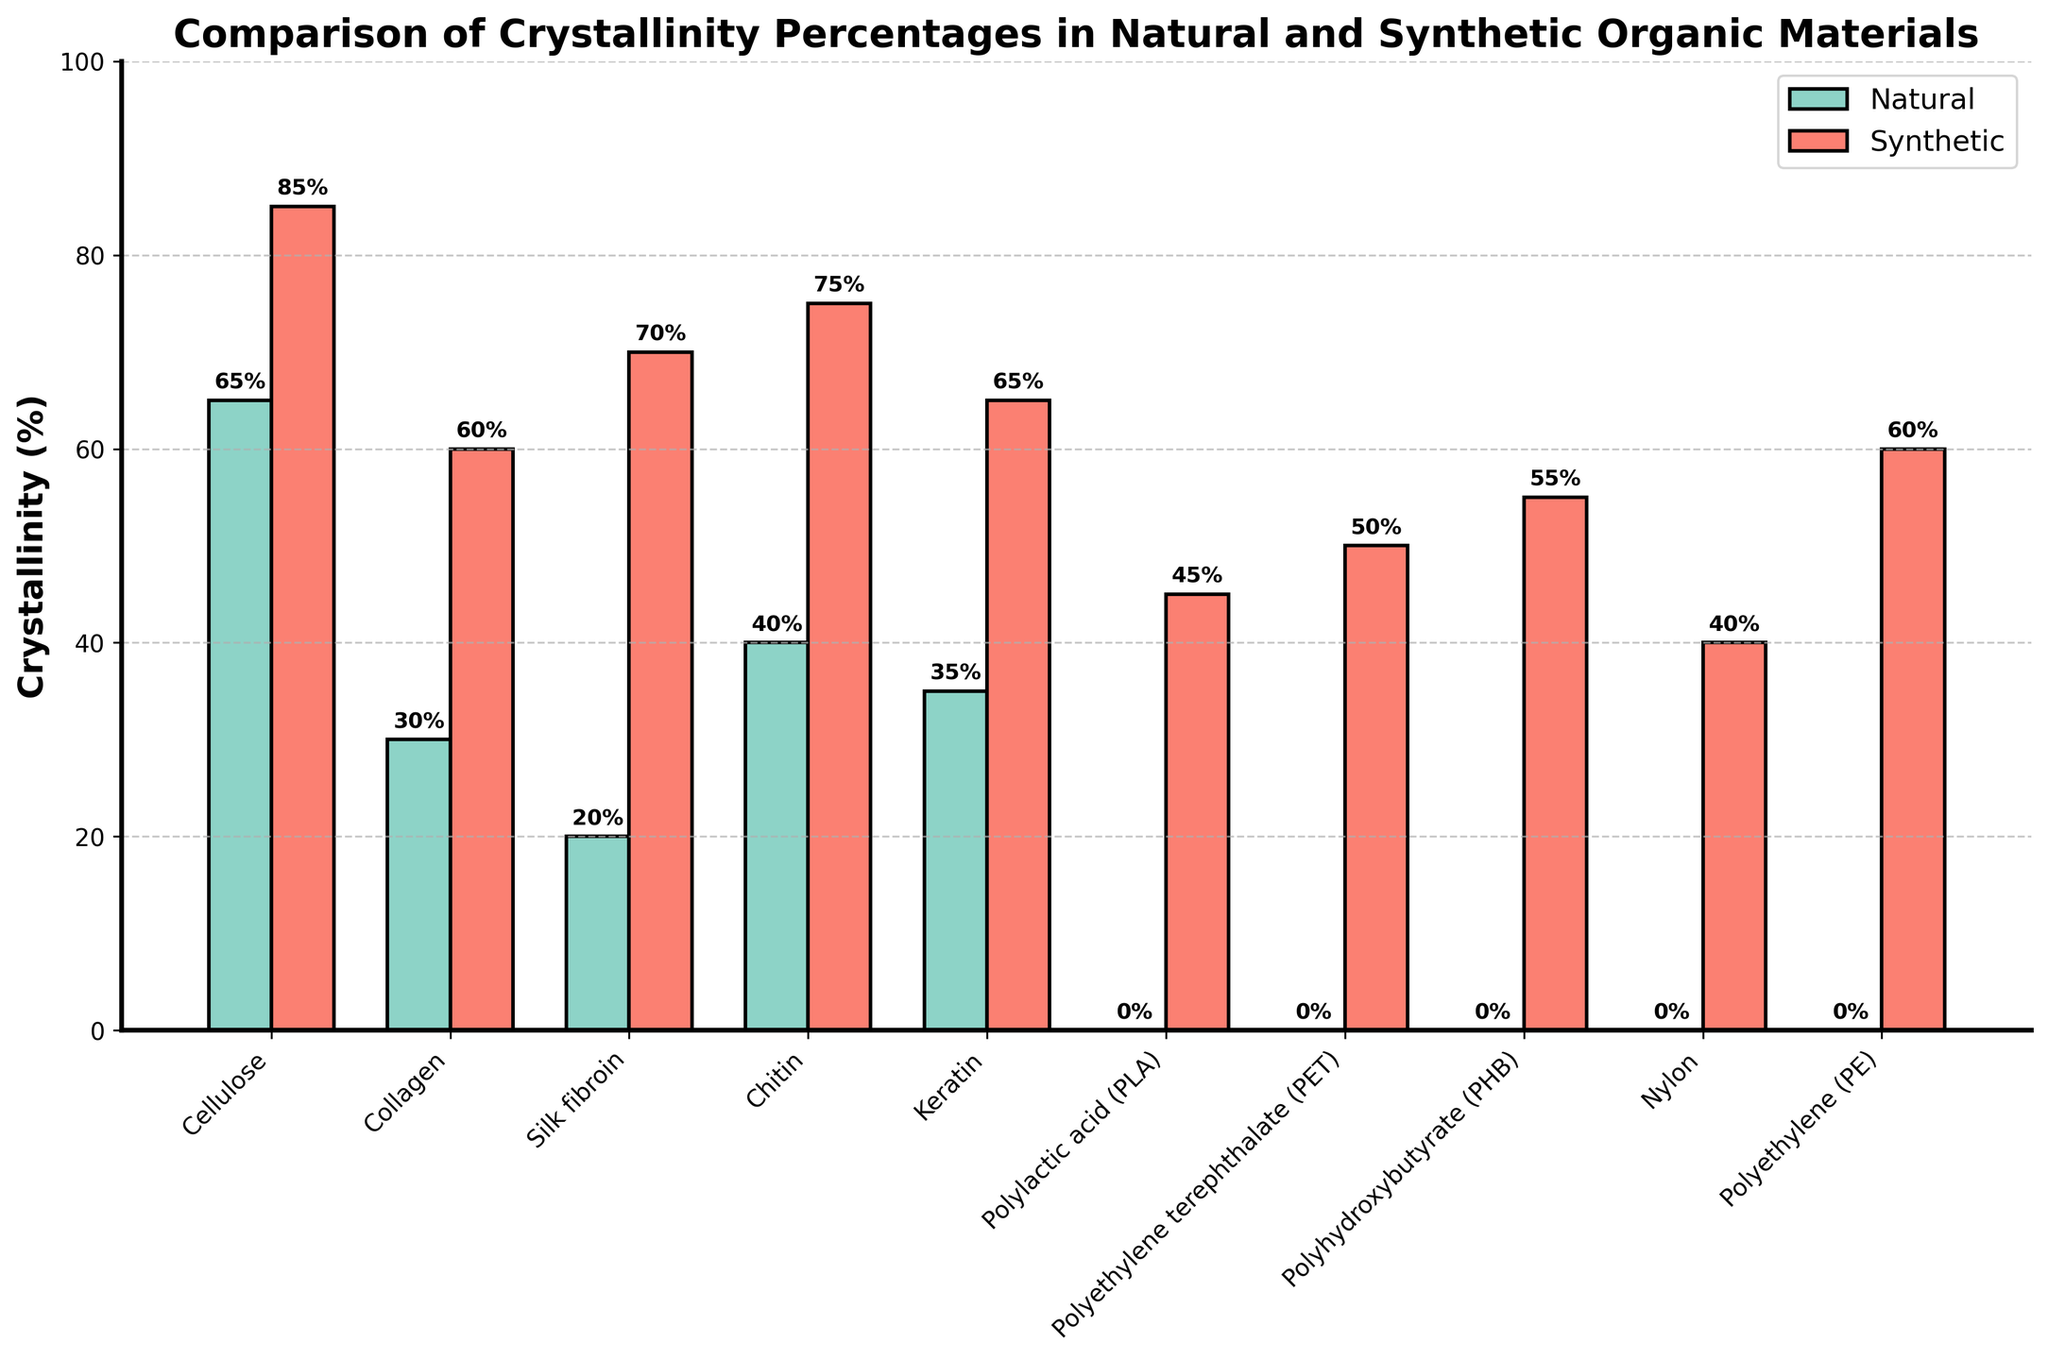What's the highest crystallinity percentage among natural materials? Refer to the "Natural Crystallinity (%)" bars and identify the tallest bar. The tallest natural bar is for Cellulose at 65%.
Answer: 65% Which synthetic material has the lowest crystallinity percentage? Refer to the "Synthetic Crystallinity (%)" bars and identify the shortest bar. The shortest synthetic bar is for Nylon at 40%.
Answer: Nylon What is the difference in crystallinity percentage between natural and synthetic Chitin? Look at the bars for Chitin: the natural crystallinity is 40% and the synthetic crystallinity is 75%. The difference is calculated by subtracting the natural percentage from the synthetic: 75% - 40% = 35%.
Answer: 35% Which material shows the largest variation in crystallinity percentage between its natural and synthetic forms? Observe both the natural and synthetic crystallinity percentages for each material, then calculate the difference for each pair. The largest difference is for Silk fibroin: 70% - 20% = 50%.
Answer: Silk fibroin Are there any materials with identical natural crystallinity percentages? By examining the heights of the bars in the "Natural Crystallinity (%)" category, check if any bars are of the same height. No such bars exist.
Answer: No What is the average crystallinity percentage of synthetic materials? Sum all the synthetic crystallinity percentages (85% + 60% + 70% + 75% + 65% + 45% + 50% + 55% + 40% + 60%) = 605%. There are 10 data points, so the average is 605% / 10 = 60.5%.
Answer: 60.5% Is polyethylene (PE) more crystalline in its natural or synthetic form? Compare the heights of the natural and synthetic bars for polyethylene (PE). The natural crystallinity is 0% and the synthetic crystallinity is 60%. Therefore, PE is more crystalline in its synthetic form.
Answer: Synthetic Which material has the closest crystallinity percentages between its natural and synthetic forms? Calculate the difference between natural and synthetic crystallinity percentages for each material and find the smallest difference. Chitin has the smallest difference: 75% - 40% = 35%.
Answer: Chitin What is the total crystallinity percentage for all natural materials combined? Sum all the natural crystallinity percentages (65% + 30% + 20% + 40% + 35% + 0% + 0% + 0% + 0% + 0%) = 190%.
Answer: 190% How many materials have a natural crystallinity percentage higher than 30%? Count the bars in the "Natural Crystallinity (%)" category that exceed 30%. Materials are Cellulose (65%), Chitin (40%), and Keratin (35%). The count is 3.
Answer: 3 